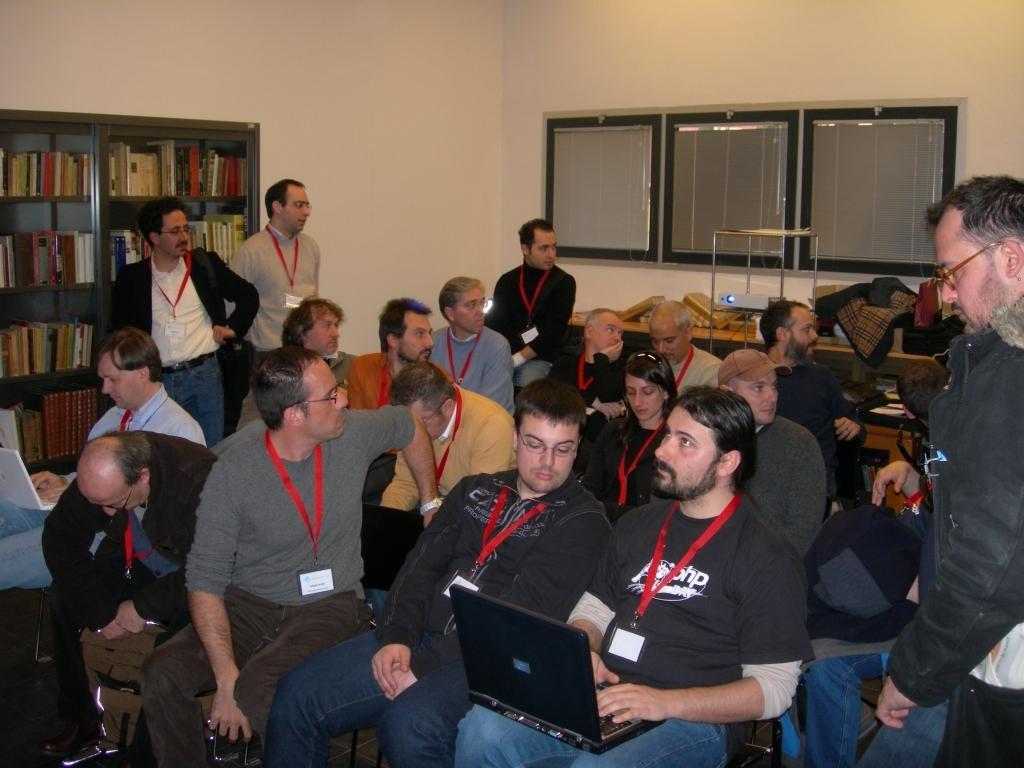Could you give a brief overview of what you see in this image? This picture shows few men seated and few are standing and all the people wore id cards and we see few of them holding laptops in their hands and we see a projector and few clothes on the table and we see a bookshelf on the left with books in it. 